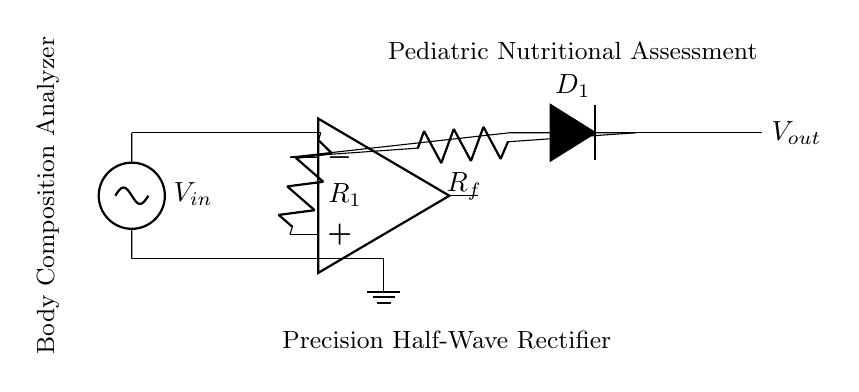What is the input voltage in the circuit? The input voltage is labeled as V in the circuit diagram, specifically indicated at the left side where it enters the circuit.
Answer: V in What type of rectifier is represented in this circuit? The circuit diagram clearly indicates that it is a precision half-wave rectifier, as stated in the label below the components.
Answer: Precision half-wave What components are in the feedback loop? The feedback loop consists of the operational amplifier and the resistor labeled R f, creating a pathway for feedback to help stabilize the output.
Answer: Operational amplifier and R f What does the diode in the circuit do? The diode D 1 allows current to flow in only one direction, effectively blocking the negative portion of the input signal, which is characteristic of half-wave rectification.
Answer: Blocks negative current What would happen to the output if the input voltage is negative? If the input voltage is negative, the diode D 1 will become reverse-biased and prevent any current flow to the output, resulting in an output voltage of zero.
Answer: Output voltage will be zero How does the operational amplifier affect the circuit? The operational amplifier amplifies the incoming voltage signal and controls the output voltage by ensuring it follows the input, adapting the level for precise measurement.
Answer: Amplifies the signal 